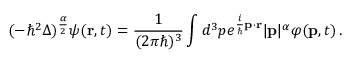Convert formula to latex. <formula><loc_0><loc_0><loc_500><loc_500>( - \hbar { ^ } { 2 } \Delta ) ^ { \frac { \alpha } { 2 } } \psi ( r , t ) = { \frac { 1 } { ( 2 \pi \hbar { ) } ^ { 3 } } } \int d ^ { 3 } p e ^ { { \frac { i } { } } p \cdot r } | p | ^ { \alpha } \varphi ( p , t ) \, .</formula> 